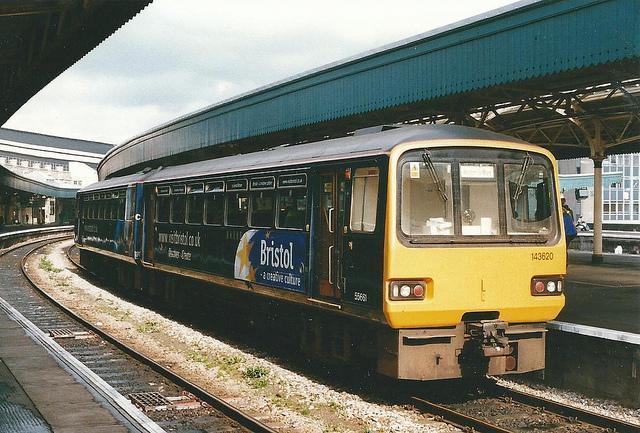How many train tracks are visible?
Give a very brief answer. 2. How many seats can you see?
Give a very brief answer. 0. How many zebras are there?
Give a very brief answer. 0. 